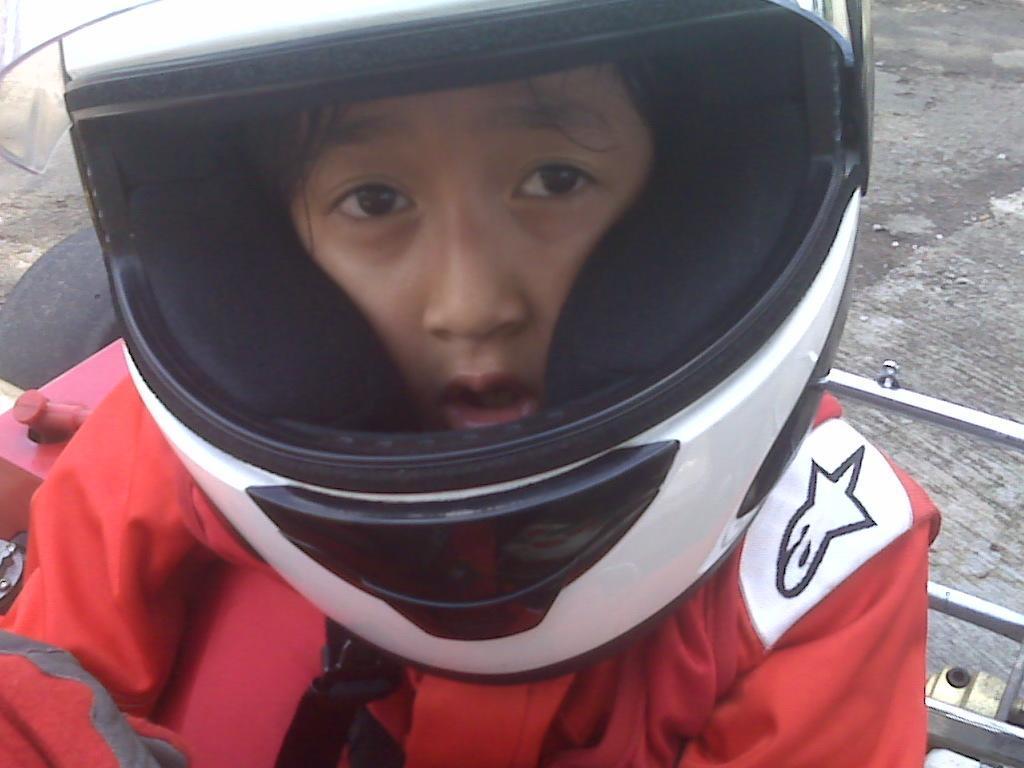In one or two sentences, can you explain what this image depicts? There is a person in orange color jacket, wearing a helmet and sitting on a seat of a vehicle. In the background, there is a road. 